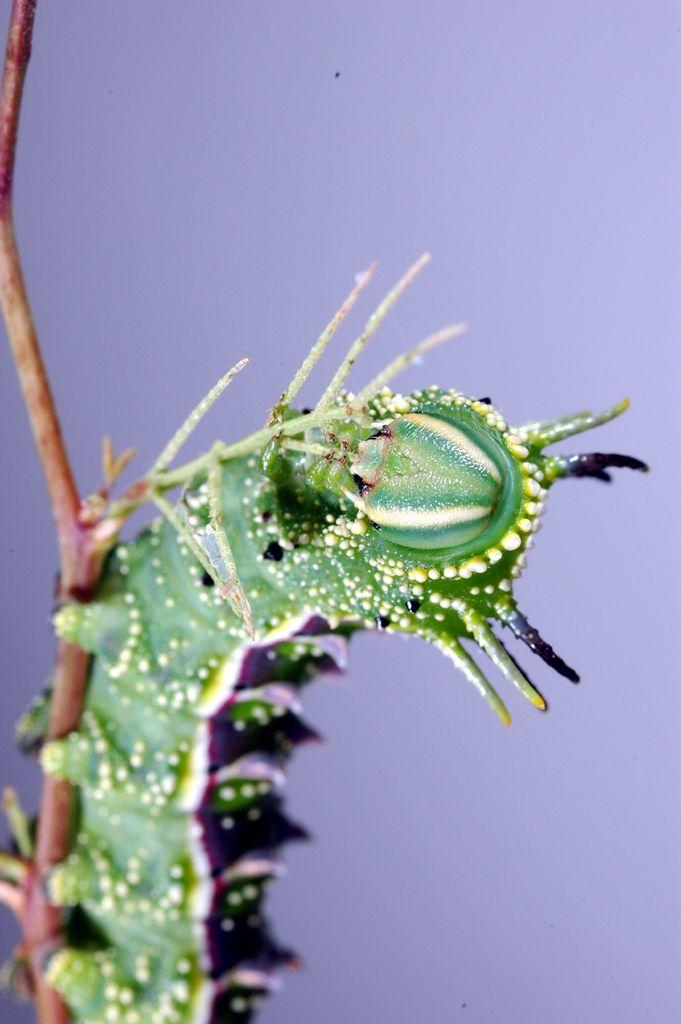What type of animal is in the image? There is a caterpillar in the image. What color is the caterpillar? The caterpillar is green. What color is the background of the image? The background of the image is purple. How many mittens can be seen in the image? There are no mittens present in the image. What type of birds are flying in the image? There are no birds present in the image. 